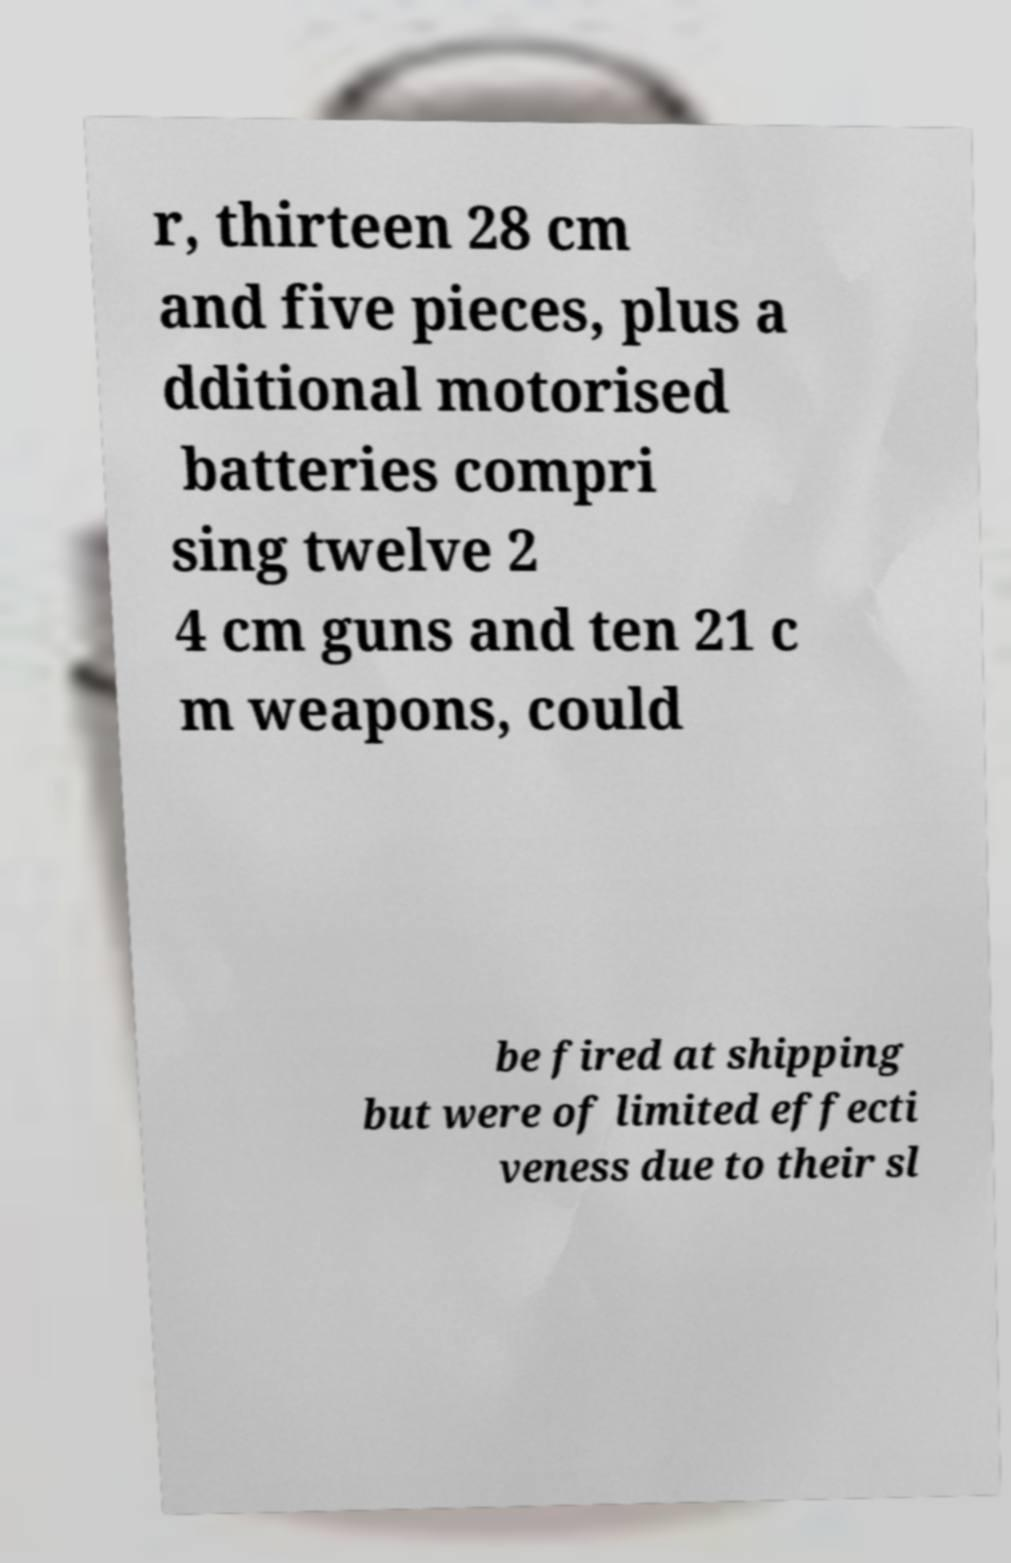What messages or text are displayed in this image? I need them in a readable, typed format. r, thirteen 28 cm and five pieces, plus a dditional motorised batteries compri sing twelve 2 4 cm guns and ten 21 c m weapons, could be fired at shipping but were of limited effecti veness due to their sl 